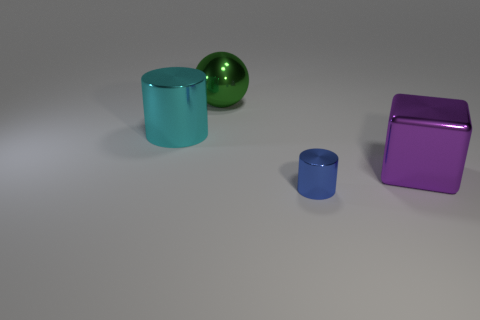Add 2 big purple things. How many objects exist? 6 Subtract 1 cylinders. How many cylinders are left? 1 Subtract all blue cylinders. How many cylinders are left? 1 Add 1 small blue objects. How many small blue objects are left? 2 Add 4 brown matte cylinders. How many brown matte cylinders exist? 4 Subtract 0 purple cylinders. How many objects are left? 4 Subtract all balls. How many objects are left? 3 Subtract all blue cylinders. Subtract all brown balls. How many cylinders are left? 1 Subtract all cylinders. Subtract all metal spheres. How many objects are left? 1 